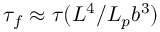<formula> <loc_0><loc_0><loc_500><loc_500>\tau _ { f } \approx \tau ( L ^ { 4 } / L _ { p } b ^ { 3 } )</formula> 